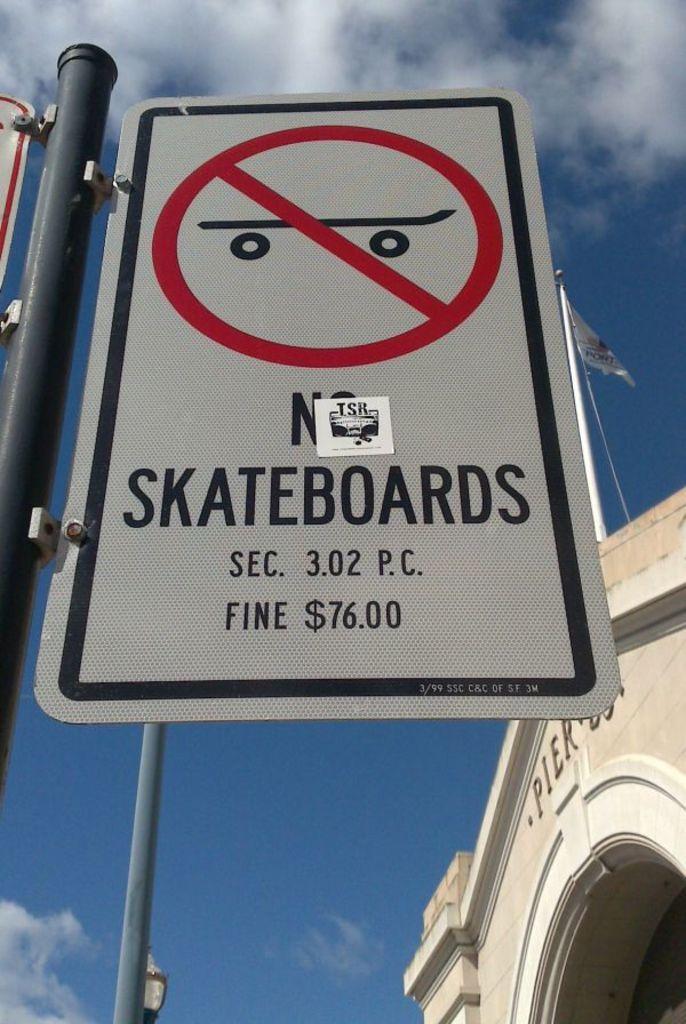Please provide a concise description of this image. In this image we can see a sign board. In the background there is a building and we can see poles. There is sky. 